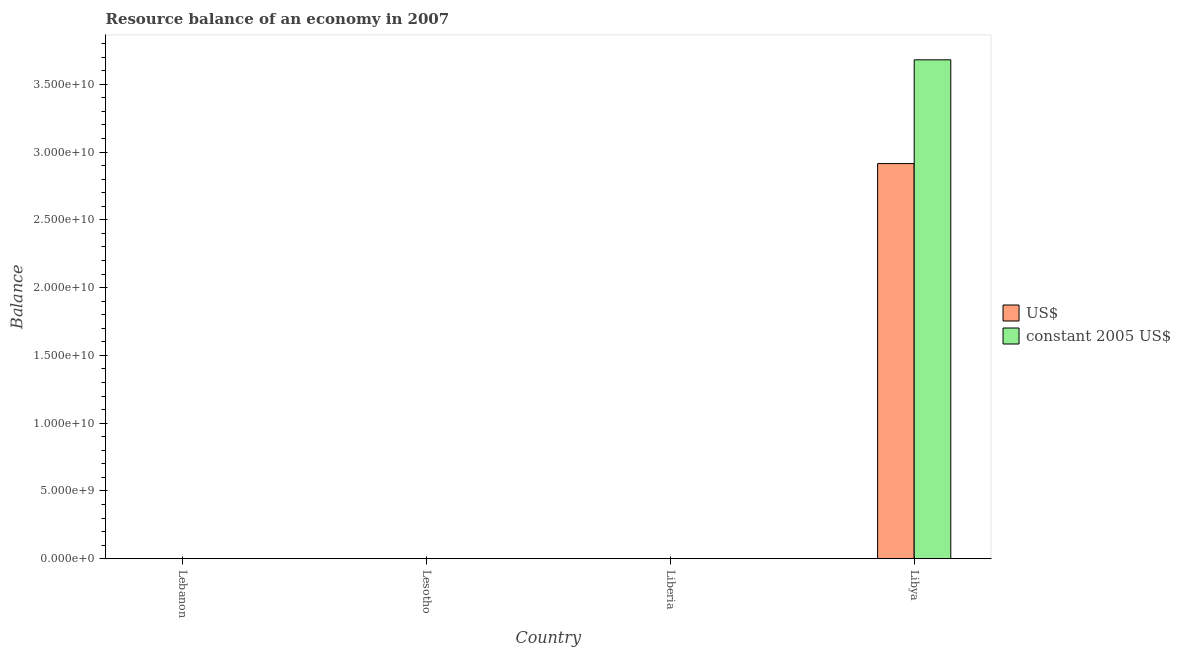How many bars are there on the 3rd tick from the right?
Offer a very short reply. 0. What is the label of the 1st group of bars from the left?
Your response must be concise. Lebanon. Across all countries, what is the maximum resource balance in us$?
Your answer should be compact. 2.91e+1. Across all countries, what is the minimum resource balance in us$?
Provide a succinct answer. 0. In which country was the resource balance in constant us$ maximum?
Your answer should be very brief. Libya. What is the total resource balance in constant us$ in the graph?
Provide a succinct answer. 3.68e+1. What is the average resource balance in constant us$ per country?
Your response must be concise. 9.20e+09. What is the difference between the resource balance in constant us$ and resource balance in us$ in Libya?
Ensure brevity in your answer.  7.65e+09. What is the difference between the highest and the lowest resource balance in constant us$?
Offer a terse response. 3.68e+1. How many bars are there?
Your response must be concise. 2. Are all the bars in the graph horizontal?
Ensure brevity in your answer.  No. How many countries are there in the graph?
Your response must be concise. 4. Are the values on the major ticks of Y-axis written in scientific E-notation?
Make the answer very short. Yes. Does the graph contain any zero values?
Your response must be concise. Yes. Does the graph contain grids?
Your answer should be very brief. No. Where does the legend appear in the graph?
Offer a very short reply. Center right. How many legend labels are there?
Give a very brief answer. 2. How are the legend labels stacked?
Provide a short and direct response. Vertical. What is the title of the graph?
Your response must be concise. Resource balance of an economy in 2007. Does "Male entrants" appear as one of the legend labels in the graph?
Your response must be concise. No. What is the label or title of the X-axis?
Give a very brief answer. Country. What is the label or title of the Y-axis?
Offer a very short reply. Balance. What is the Balance of US$ in Lebanon?
Keep it short and to the point. 0. What is the Balance in constant 2005 US$ in Liberia?
Your response must be concise. 0. What is the Balance in US$ in Libya?
Provide a succinct answer. 2.91e+1. What is the Balance of constant 2005 US$ in Libya?
Your response must be concise. 3.68e+1. Across all countries, what is the maximum Balance of US$?
Your response must be concise. 2.91e+1. Across all countries, what is the maximum Balance in constant 2005 US$?
Your answer should be compact. 3.68e+1. What is the total Balance in US$ in the graph?
Offer a terse response. 2.91e+1. What is the total Balance of constant 2005 US$ in the graph?
Provide a succinct answer. 3.68e+1. What is the average Balance in US$ per country?
Your answer should be very brief. 7.29e+09. What is the average Balance in constant 2005 US$ per country?
Your response must be concise. 9.20e+09. What is the difference between the Balance in US$ and Balance in constant 2005 US$ in Libya?
Your answer should be compact. -7.65e+09. What is the difference between the highest and the lowest Balance of US$?
Your response must be concise. 2.91e+1. What is the difference between the highest and the lowest Balance in constant 2005 US$?
Provide a short and direct response. 3.68e+1. 